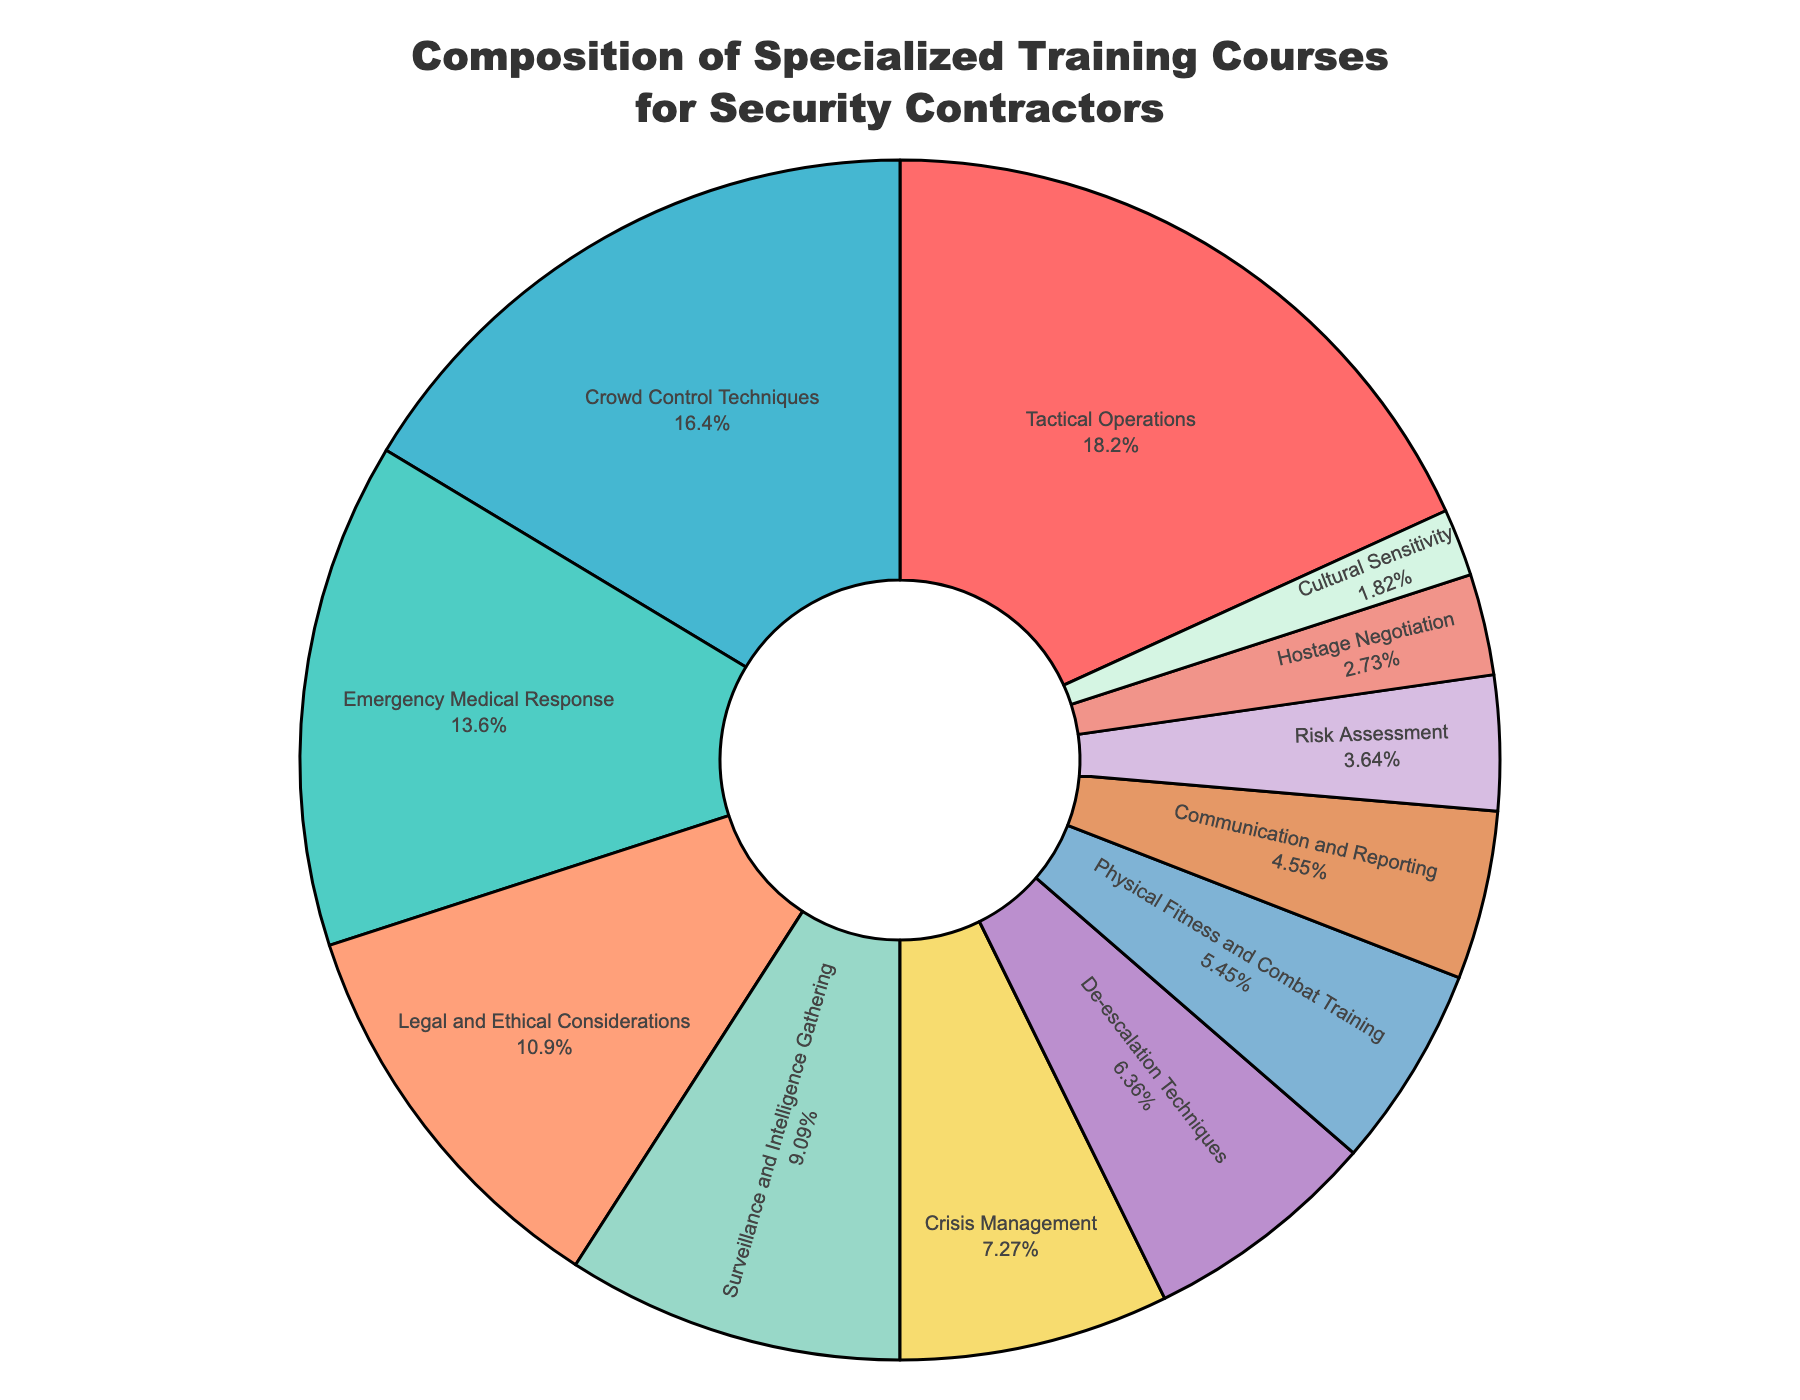What percentage of the training courses are dedicated to Tactical Operations and Emergency Medical Response combined? Add the percentages for both categories: Tactical Operations (20%) + Emergency Medical Response (15%) = 35%
Answer: 35% Which training category has the smallest percentage, and what is that percentage? The smallest percentage is for Cultural Sensitivity, which is 2%
Answer: Cultural Sensitivity, 2% Is the percentage of training courses for Crowd Control Techniques greater or smaller than the percentage for Surveillance and Intelligence Gathering? Compare the percentages: Crowd Control Techniques (18%) is greater than Surveillance and Intelligence Gathering (10%)
Answer: Greater How much more emphasis is placed on De-escalation Techniques compared to Physical Fitness and Combat Training? Subtract the percentage of Physical Fitness and Combat Training (6%) from De-escalation Techniques (7%): 7% - 6% = 1%
Answer: 1% What are the top three categories in terms of percentage, and what are their combined percentages? Identify the top three categories by percentage: Tactical Operations (20%), Crowd Control Techniques (18%), and Emergency Medical Response (15%). Add their percentages: 20% + 18% + 15% = 53%
Answer: Tactical Operations, Crowd Control Techniques, Emergency Medical Response, 53% Which training category is represented by the blue section of the pie chart? The blue section corresponds to Tactical Operations.
Answer: Tactical Operations What is the difference in percentage between the largest and smallest training categories? Subtract the smallest percentage (Cultural Sensitivity, 2%) from the largest (Tactical Operations, 20%): 20% - 2% = 18%
Answer: 18% Is the percentage of training courses for Crisis Management higher than that for De-escalation Techniques and Communication and Reporting combined? Compare: Crisis Management (8%) vs. De-escalation Techniques (7%) + Communication and Reporting (5%) = 12%. 8% is less than 12%.
Answer: No How do the percentages for Legal and Ethical Considerations and Risk Assessment compare, and what is the difference? Compare percentages: Legal and Ethical Considerations (12%) vs. Risk Assessment (4%). Difference: 12% - 4% = 8%
Answer: Legal and Ethical Considerations is greater by 8% What percentage of the training courses is allocated to interpersonal skills (consider Communication and Reporting, Hostage Negotiation, and Cultural Sensitivity)? Sum the percentages for these categories: Communication and Reporting (5%) + Hostage Negotiation (3%) + Cultural Sensitivity (2%) = 10%
Answer: 10% 